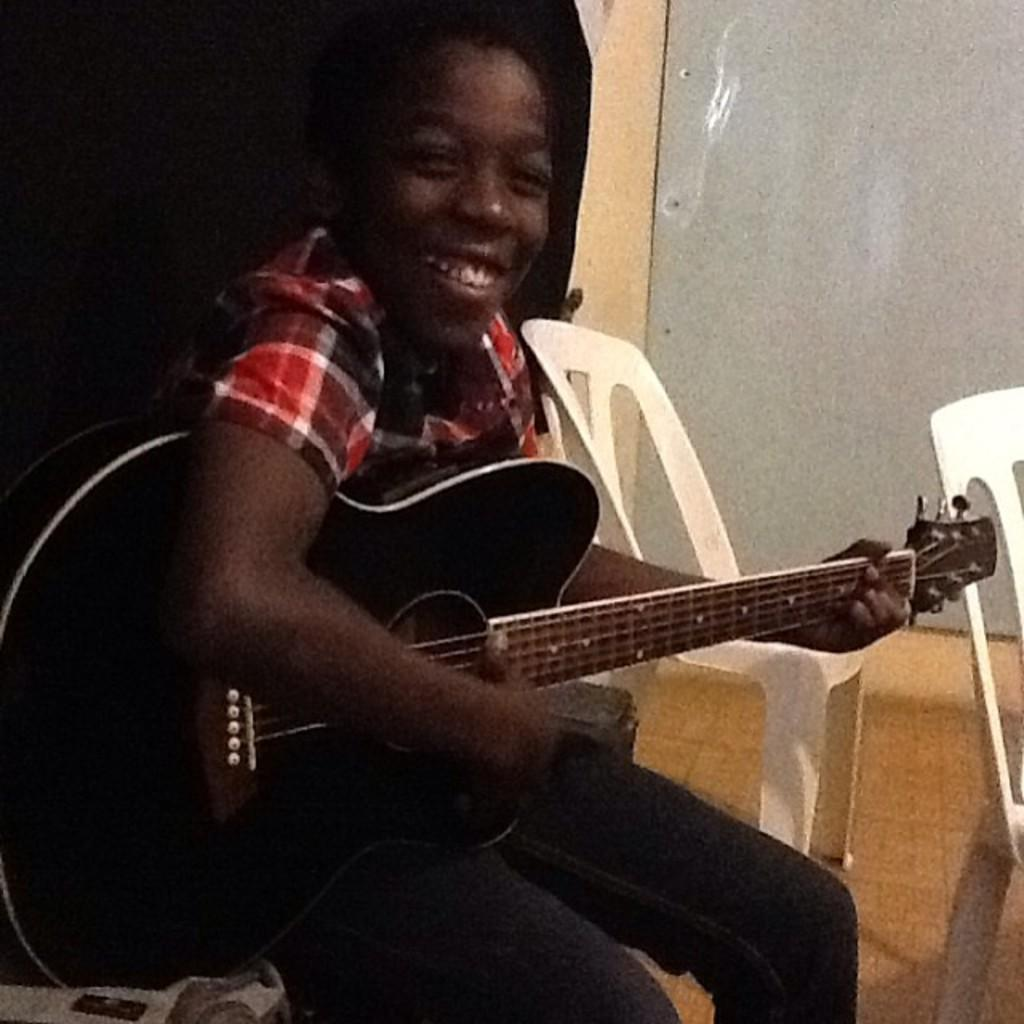What is the person in the image doing? The person is playing a guitar. What is the person's facial expression in the image? The person is smiling. What can be seen on the floor in the image? There are chairs on the floor. What is visible in the background of the image? There is a wall in the background of the image. What type of drug can be seen in the image? There is no drug present in the image. What is the aftermath of the person playing the guitar in the image? The image does not depict any aftermath, as it shows the person playing the guitar in real-time. 